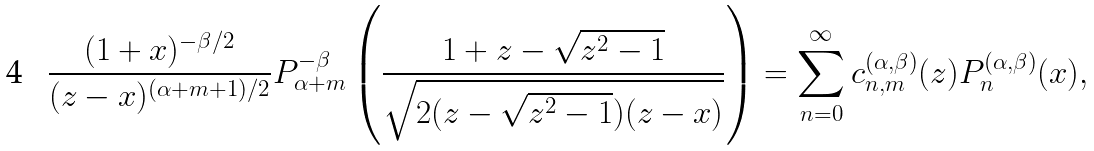Convert formula to latex. <formula><loc_0><loc_0><loc_500><loc_500>\frac { ( 1 + x ) ^ { - \beta / 2 } } { ( z - x ) ^ { ( \alpha + m + 1 ) / 2 } } P _ { \alpha + m } ^ { - \beta } \left ( \frac { 1 + z - \sqrt { z ^ { 2 } - 1 } } { \sqrt { 2 ( z - \sqrt { z ^ { 2 } - 1 } ) ( z - x ) } } \right ) = \sum _ { n = 0 } ^ { \infty } c _ { n , m } ^ { ( \alpha , \beta ) } ( z ) P _ { n } ^ { ( \alpha , \beta ) } ( x ) ,</formula> 